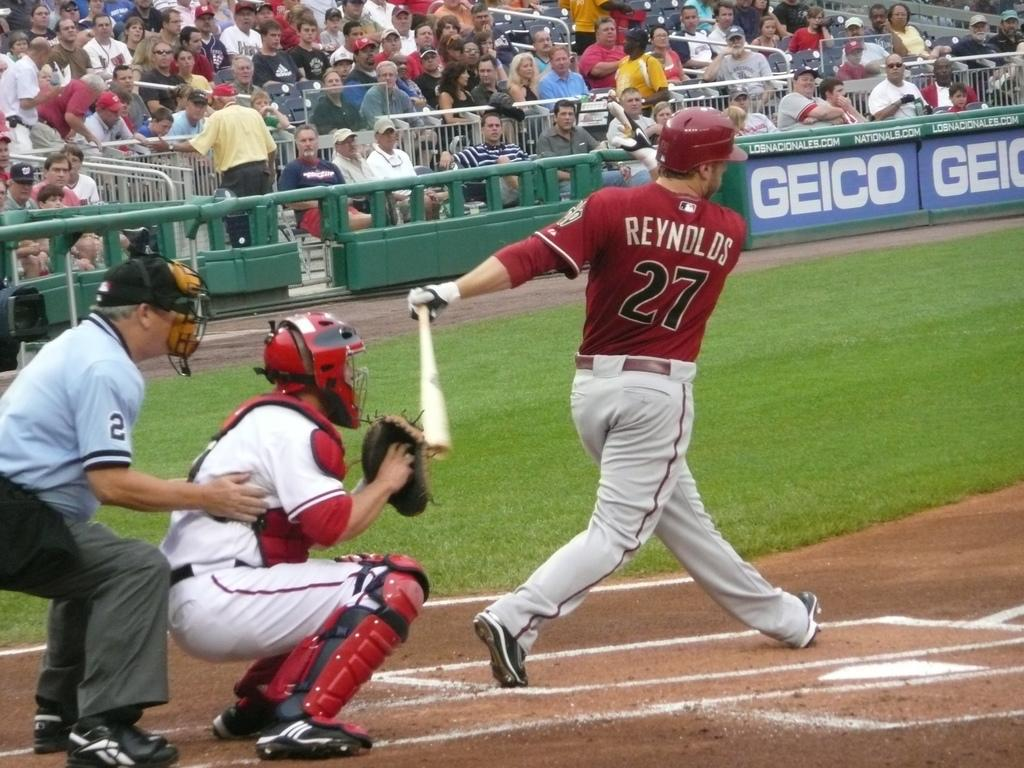Provide a one-sentence caption for the provided image. baseball game with a batter of last name Reynolds # 27 hitting the ball at home plate. 